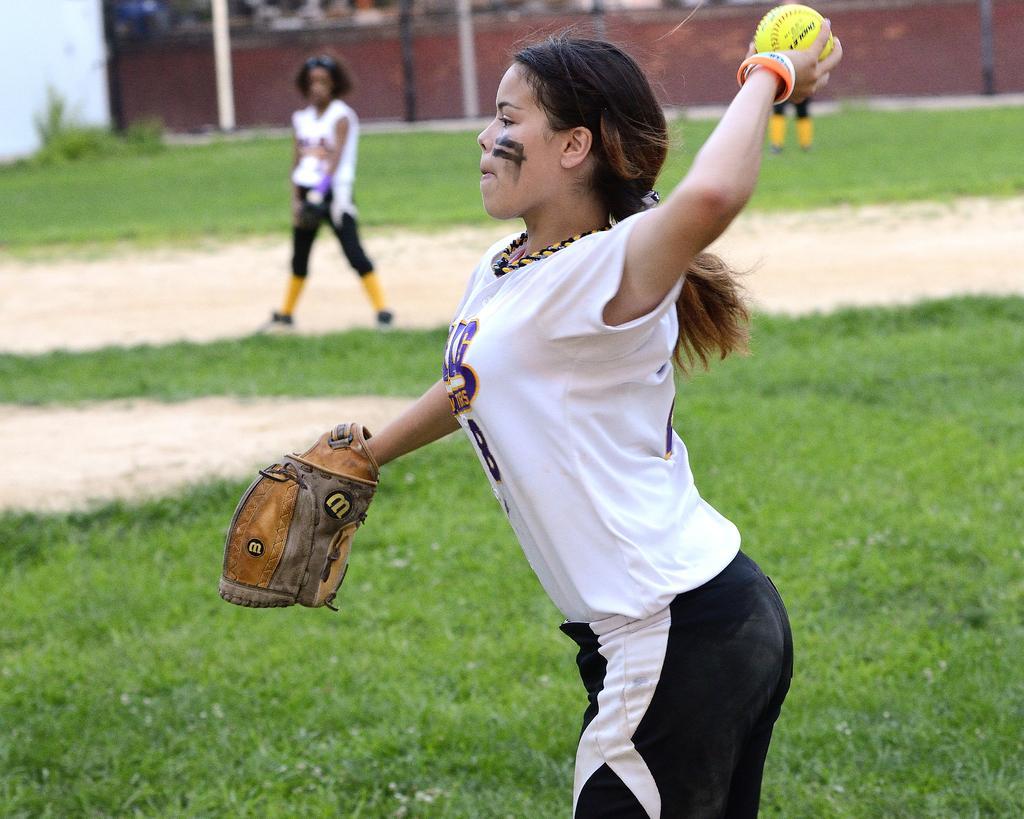Describe this image in one or two sentences. In this image a girl wearing a white sports dress. She is holding a ball with one hand and she is wearing gloves to other hand. She is standing on the grassland. A girl is standing on the land. She is wearing white sports dress. Behind her there is a wall. Before her there are few poles. 